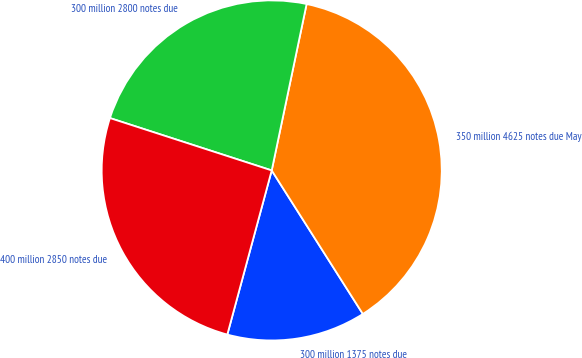Convert chart to OTSL. <chart><loc_0><loc_0><loc_500><loc_500><pie_chart><fcel>300 million 1375 notes due<fcel>350 million 4625 notes due May<fcel>300 million 2800 notes due<fcel>400 million 2850 notes due<nl><fcel>13.21%<fcel>37.71%<fcel>23.31%<fcel>25.78%<nl></chart> 